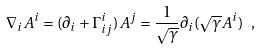Convert formula to latex. <formula><loc_0><loc_0><loc_500><loc_500>\nabla _ { i } A ^ { i } = ( \partial _ { i } + \Gamma ^ { i } _ { i j } ) A ^ { j } = \frac { 1 } { \sqrt { \gamma } } \partial _ { i } ( \sqrt { \gamma } A ^ { i } ) \ ,</formula> 